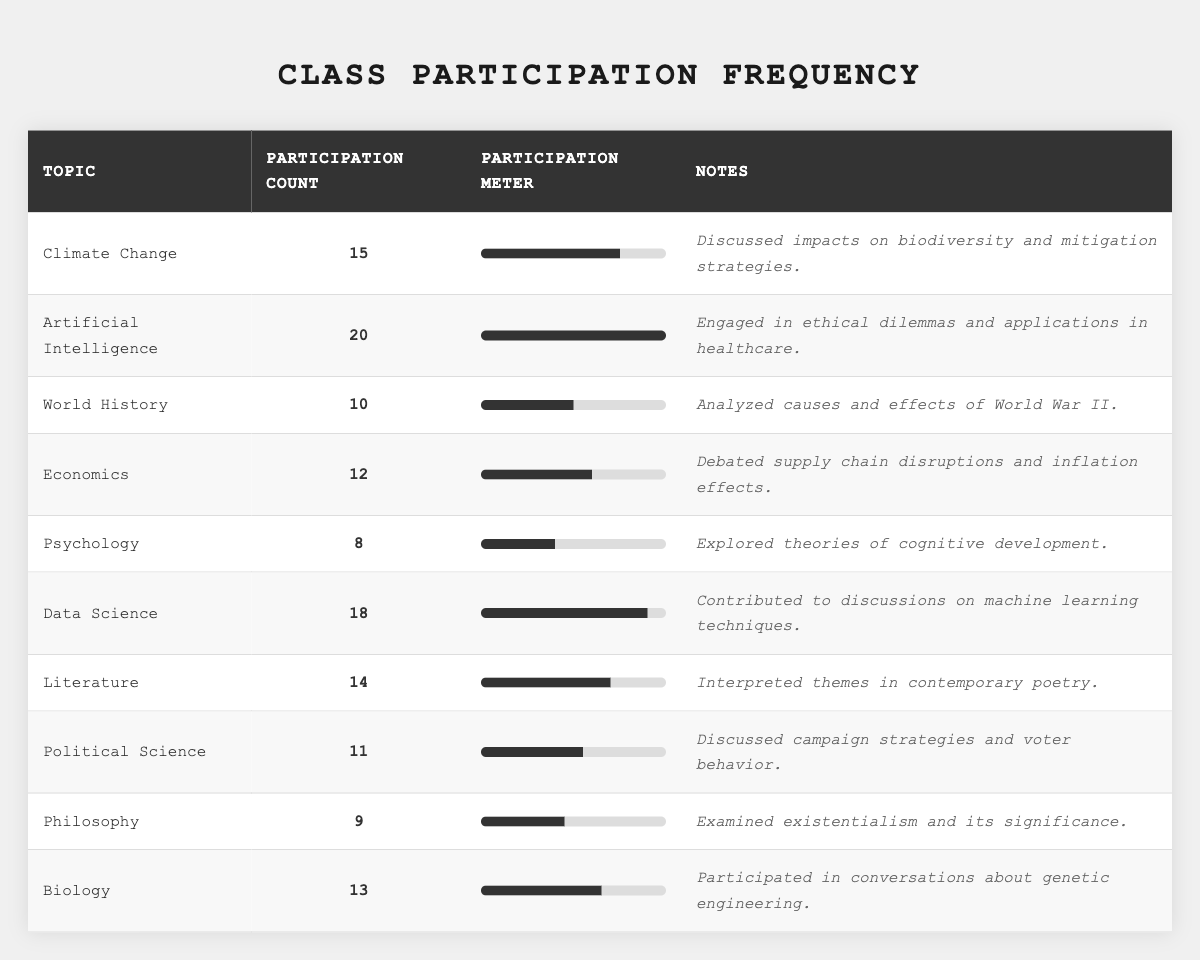What is the topic with the highest participation count? The participation counts are as follows: Climate Change (15), Artificial Intelligence (20), World History (10), Economics (12), Psychology (8), Data Science (18), Literature (14), Political Science (11), Philosophy (9), Biology (13). The highest count is 20 for Artificial Intelligence.
Answer: Artificial Intelligence Which topic had the lowest participation count? The participation counts listed show that Psychology has the lowest count at 8, compared to the other topics.
Answer: Psychology What is the average participation count across all topics? To find the average, sum the participation counts (15 + 20 + 10 + 12 + 8 + 18 + 14 + 11 + 9 + 13 =  140) and divide by the number of topics (10). Thus, 140 / 10 = 14.
Answer: 14 Is the participation count for Data Science greater than that for Economics? The participation count for Data Science is 18, while for Economics it is 12. Since 18 is greater than 12, the statement is true.
Answer: Yes How many topics had a participation count of 15 or more? The topics with a count of 15 or more are: Climate Change (15), Artificial Intelligence (20), Data Science (18), and Literature (14). This totals to 5 topics.
Answer: 5 What is the difference between the highest and lowest participation counts? The highest participation count is 20 (Artificial Intelligence) and the lowest is 8 (Psychology). The difference is calculated as 20 - 8 = 12.
Answer: 12 Which topic's participation count is closest to the average participation count? The average participation count is 14. The counts closest to 14 are Literature (14) and Biology (13). Literature matches the average exactly while Biology is just 1 less.
Answer: Literature How many more participants discussed Artificial Intelligence compared to Philosophy? The participation count for Artificial Intelligence is 20, and for Philosophy, it is 9. The difference is 20 - 9 = 11 participants.
Answer: 11 What percentage of topics have a participation count between 10 and 15? The topics with counts between 10 and 15 are World History (10), Economics (12), Political Science (11), and Literature (14), which are 4 in total. There are 10 topics altogether, so the percentage is (4/10) * 100 = 40%.
Answer: 40% Which topics had lower participation counts than Data Science? Data Science has a participation count of 18. The topics with lower counts are World History (10), Economics (12), Psychology (8), Political Science (11), Philosophy (9), and Biology (13). There are 6 such topics.
Answer: 6 